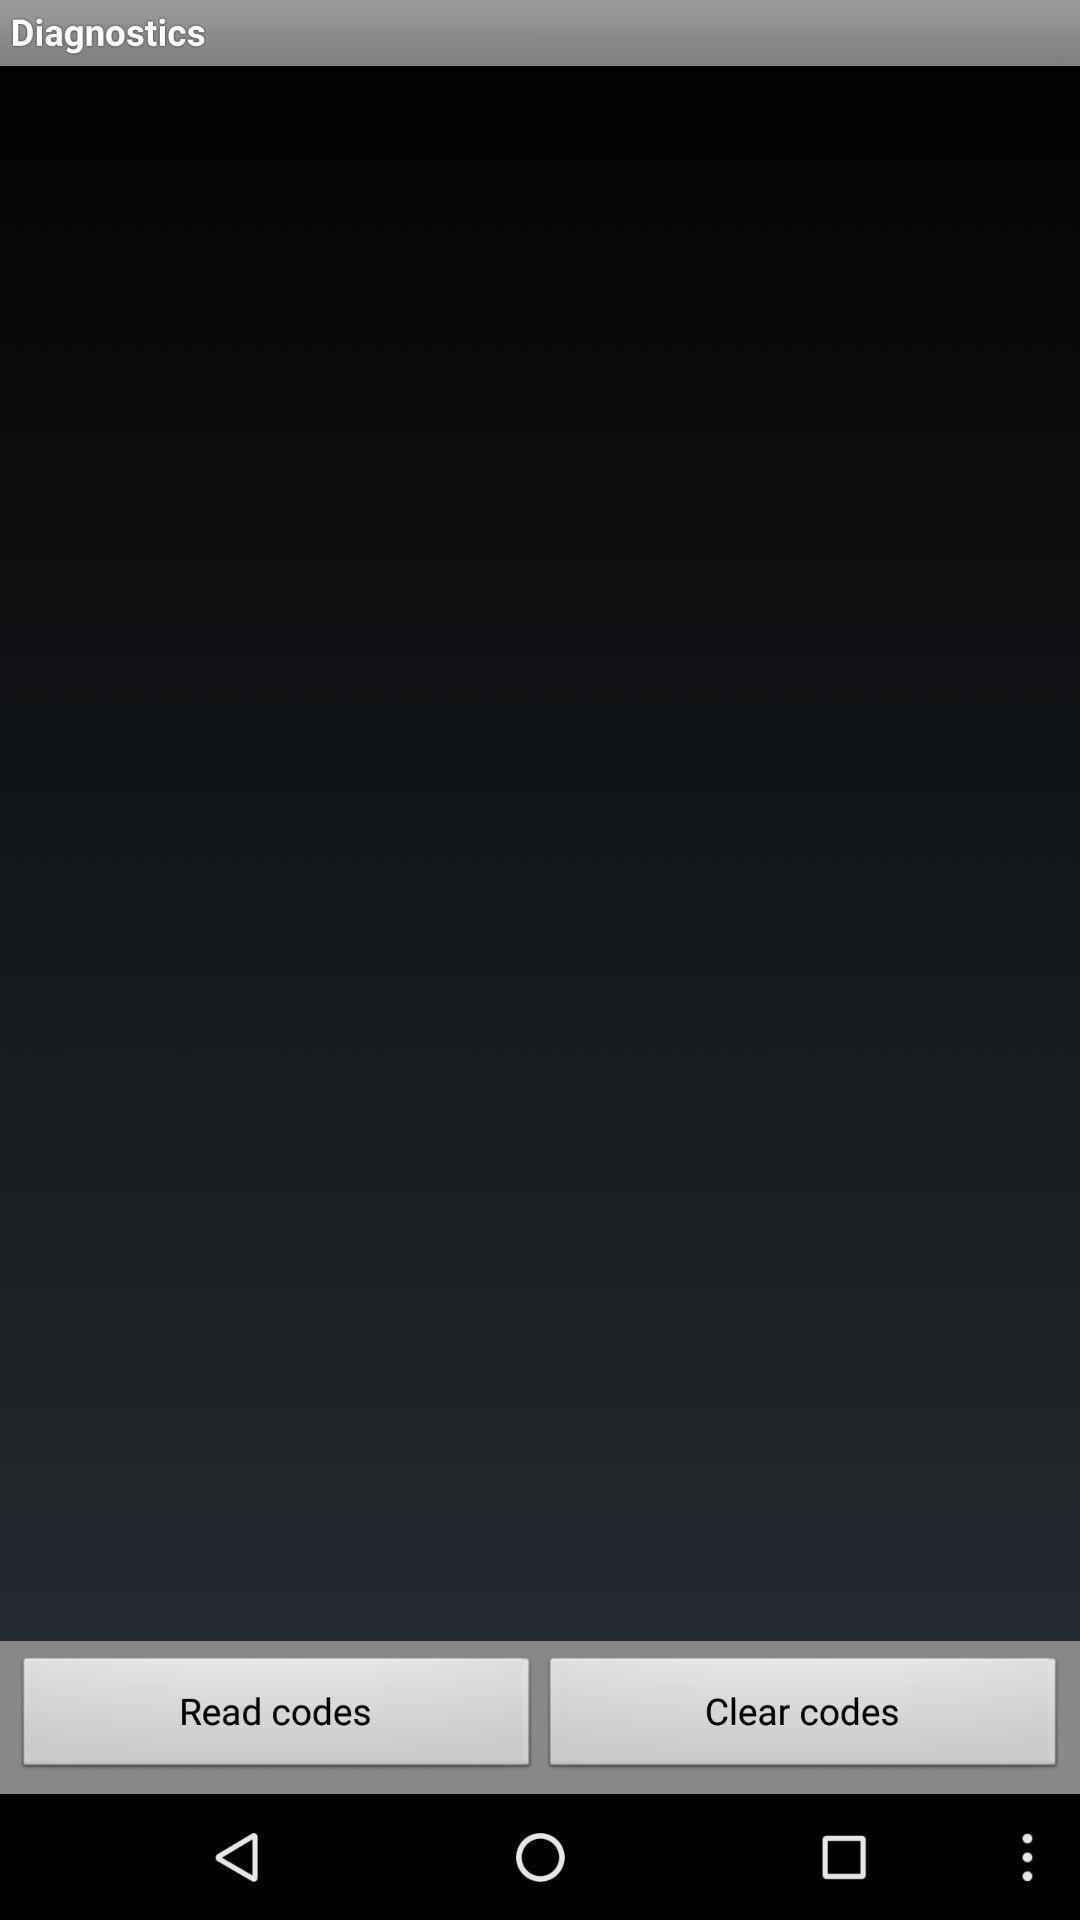Describe the content in this image. Screen displaying a blank page with multiple options. 